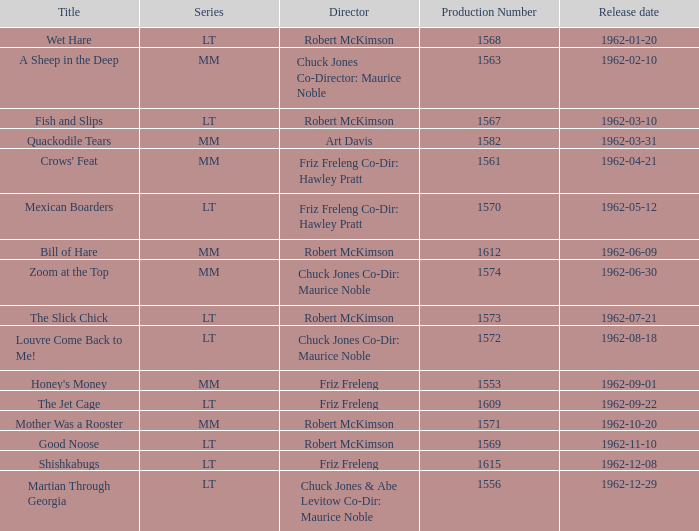What is the title of the film with production number 1553, directed by Friz Freleng? Honey's Money. 